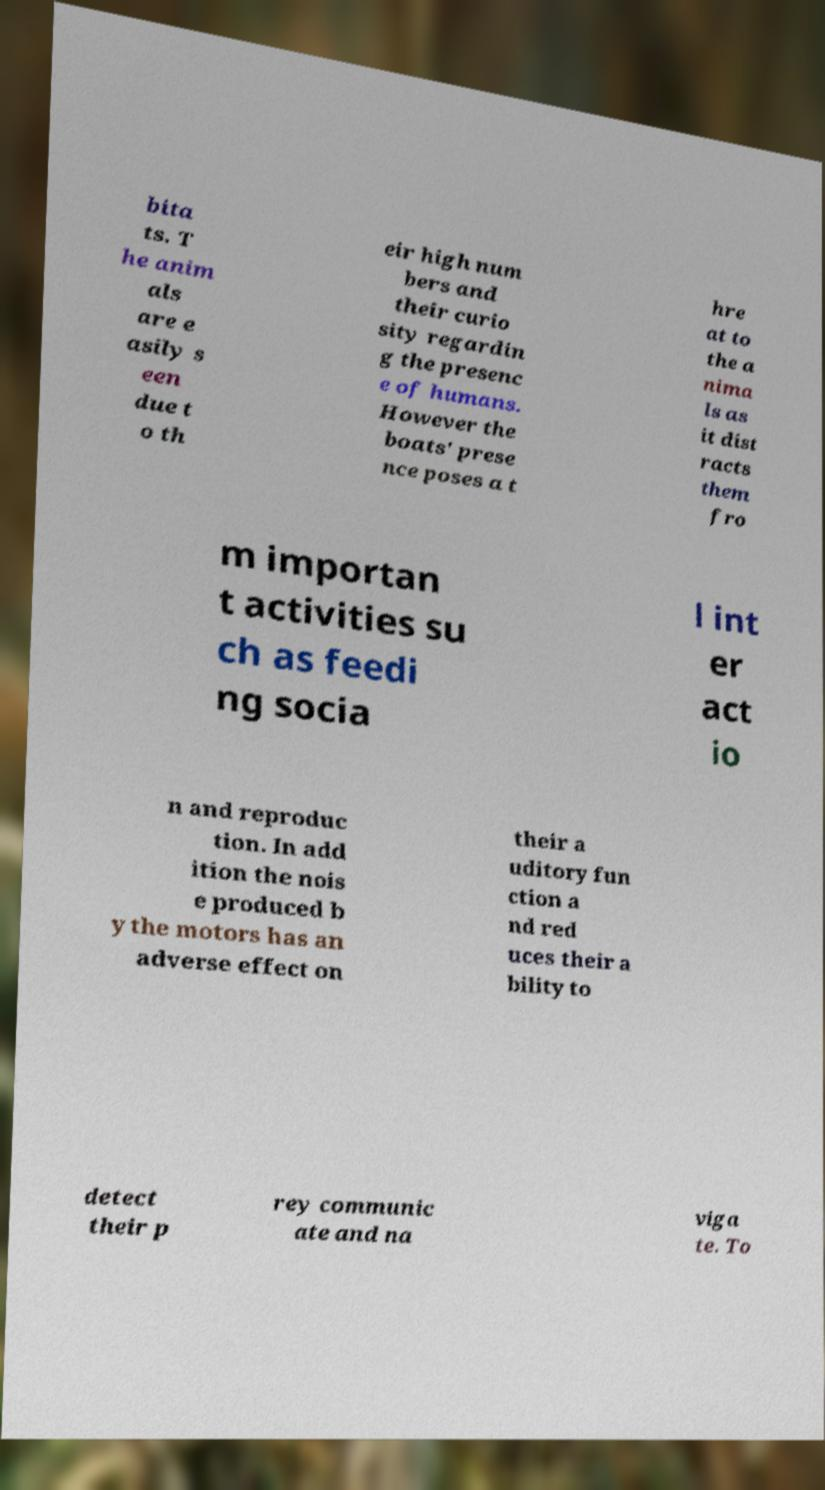There's text embedded in this image that I need extracted. Can you transcribe it verbatim? bita ts. T he anim als are e asily s een due t o th eir high num bers and their curio sity regardin g the presenc e of humans. However the boats' prese nce poses a t hre at to the a nima ls as it dist racts them fro m importan t activities su ch as feedi ng socia l int er act io n and reproduc tion. In add ition the nois e produced b y the motors has an adverse effect on their a uditory fun ction a nd red uces their a bility to detect their p rey communic ate and na viga te. To 